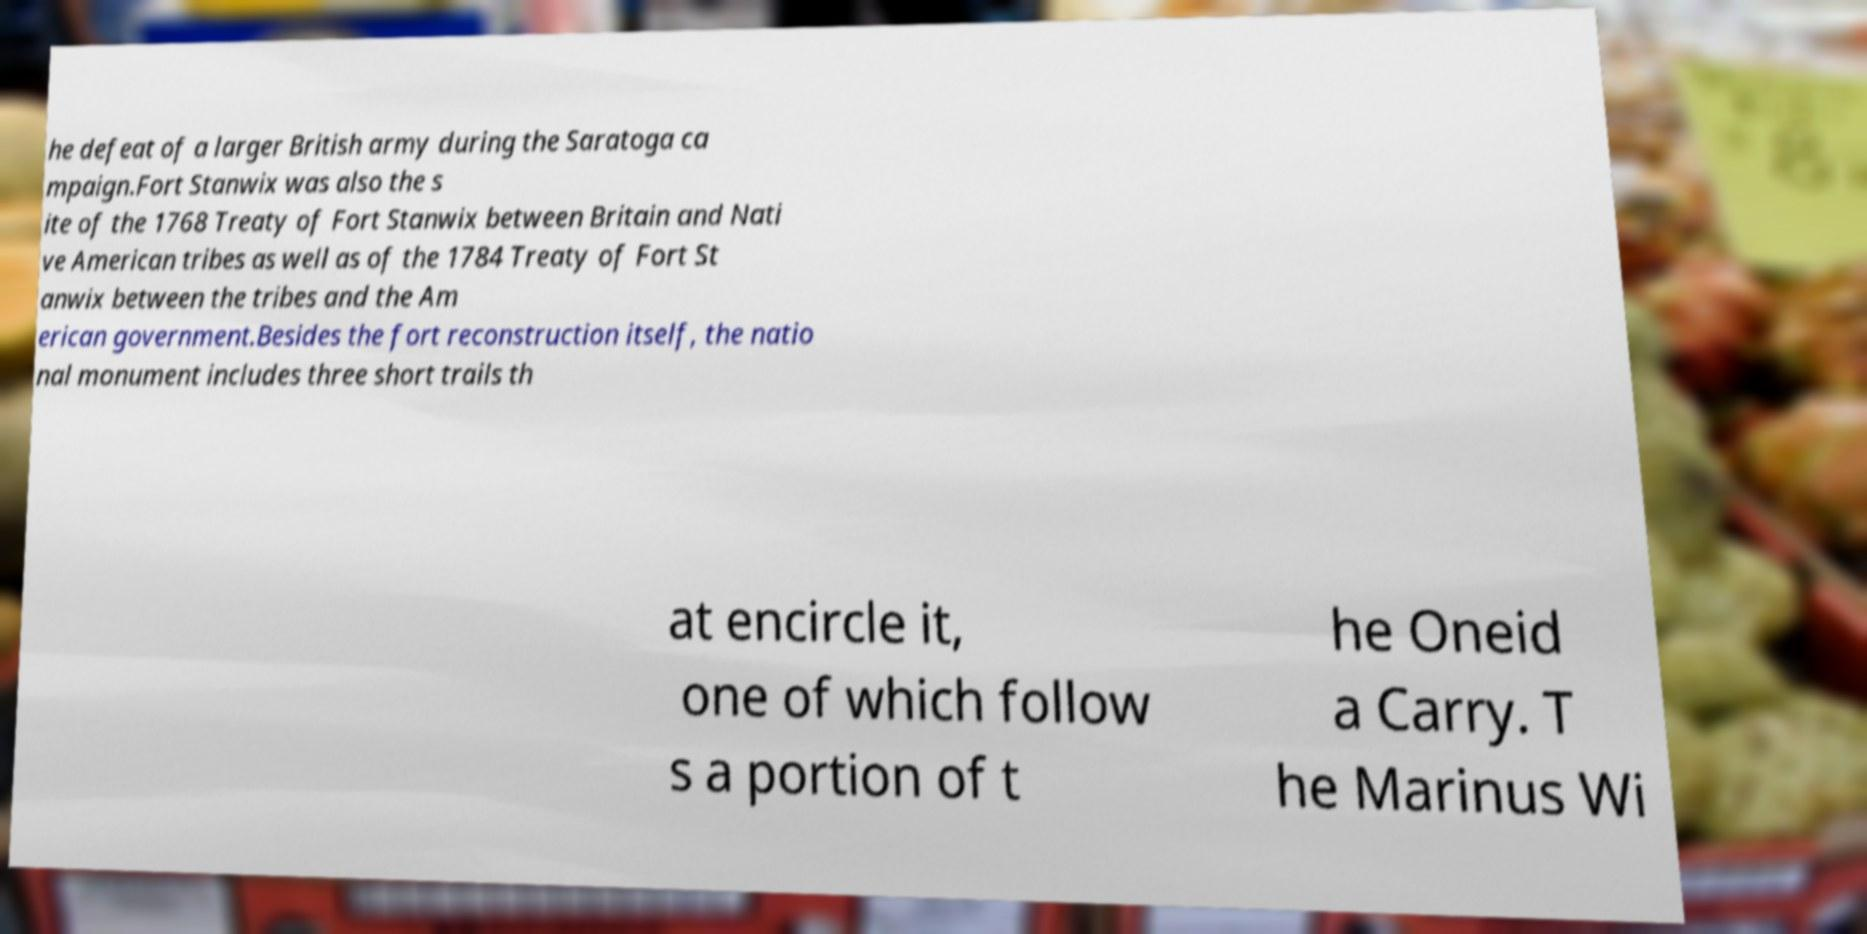Can you accurately transcribe the text from the provided image for me? he defeat of a larger British army during the Saratoga ca mpaign.Fort Stanwix was also the s ite of the 1768 Treaty of Fort Stanwix between Britain and Nati ve American tribes as well as of the 1784 Treaty of Fort St anwix between the tribes and the Am erican government.Besides the fort reconstruction itself, the natio nal monument includes three short trails th at encircle it, one of which follow s a portion of t he Oneid a Carry. T he Marinus Wi 